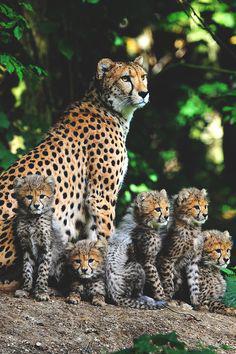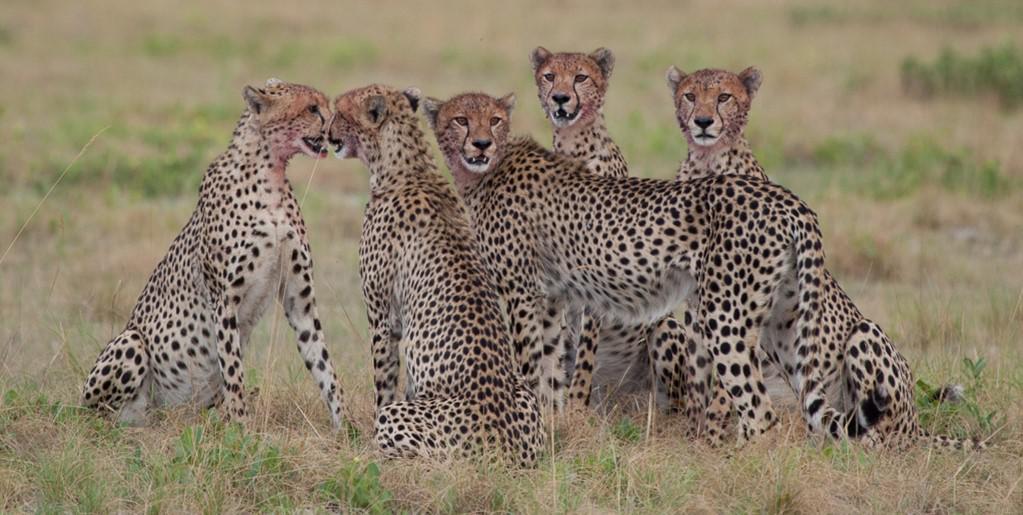The first image is the image on the left, the second image is the image on the right. For the images displayed, is the sentence "The left image contains at least four cheetahs." factually correct? Answer yes or no. Yes. The first image is the image on the left, the second image is the image on the right. For the images shown, is this caption "There are at least five cheetah in the pair of images." true? Answer yes or no. Yes. 